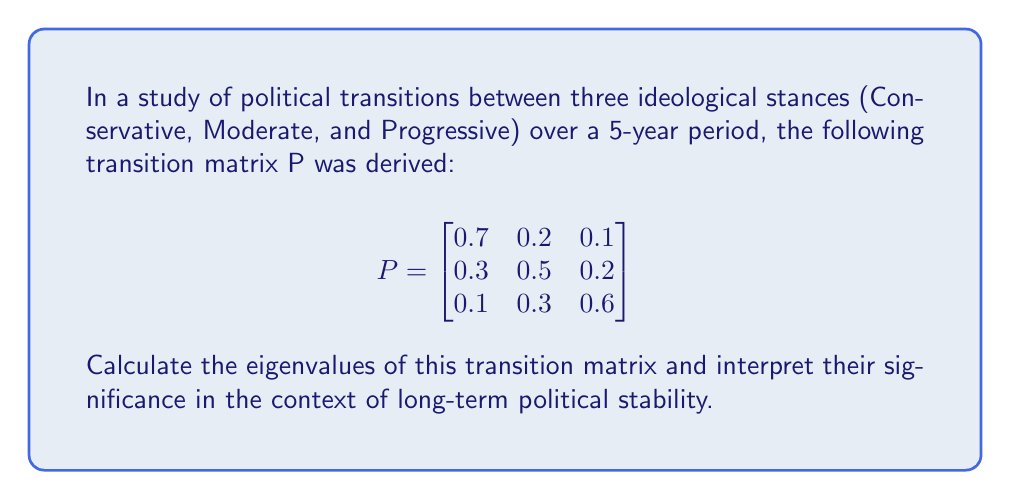Show me your answer to this math problem. To find the eigenvalues of the transition matrix P, we follow these steps:

1) The characteristic equation is given by $\det(P - \lambda I) = 0$, where $\lambda$ represents the eigenvalues and I is the 3x3 identity matrix.

2) Expand the determinant:

   $$\det\begin{bmatrix}
   0.7-\lambda & 0.2 & 0.1 \\
   0.3 & 0.5-\lambda & 0.2 \\
   0.1 & 0.3 & 0.6-\lambda
   \end{bmatrix} = 0$$

3) Calculate the determinant:

   $(0.7-\lambda)[(0.5-\lambda)(0.6-\lambda)-0.06] - 0.2[0.3(0.6-\lambda)-0.02] + 0.1[0.3(0.5-\lambda)-0.06] = 0$

4) Simplify:

   $-\lambda^3 + 1.8\lambda^2 - 0.83\lambda + 0.1 = 0$

5) Solve this cubic equation. The solutions are the eigenvalues:

   $\lambda_1 = 1$
   $\lambda_2 \approx 0.5858$
   $\lambda_3 \approx 0.2142$

Interpretation:
- The largest eigenvalue $\lambda_1 = 1$ indicates that the process is stochastic and conserves probability.
- The second largest eigenvalue $\lambda_2 \approx 0.5858$ represents the rate of convergence to the steady-state distribution. A value less than 1 suggests the system will eventually reach equilibrium.
- The smallest eigenvalue $\lambda_3 \approx 0.2142$ indicates how quickly certain political configurations decay.

These eigenvalues suggest a stable political system that will converge to a steady-state distribution of ideological stances over time.
Answer: Eigenvalues: 1, 0.5858, 0.2142 (approx.) 